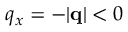Convert formula to latex. <formula><loc_0><loc_0><loc_500><loc_500>q _ { x } = - | q | < 0</formula> 